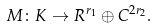Convert formula to latex. <formula><loc_0><loc_0><loc_500><loc_500>M \colon K \to R ^ { r _ { 1 } } \oplus C ^ { 2 r _ { 2 } } .</formula> 